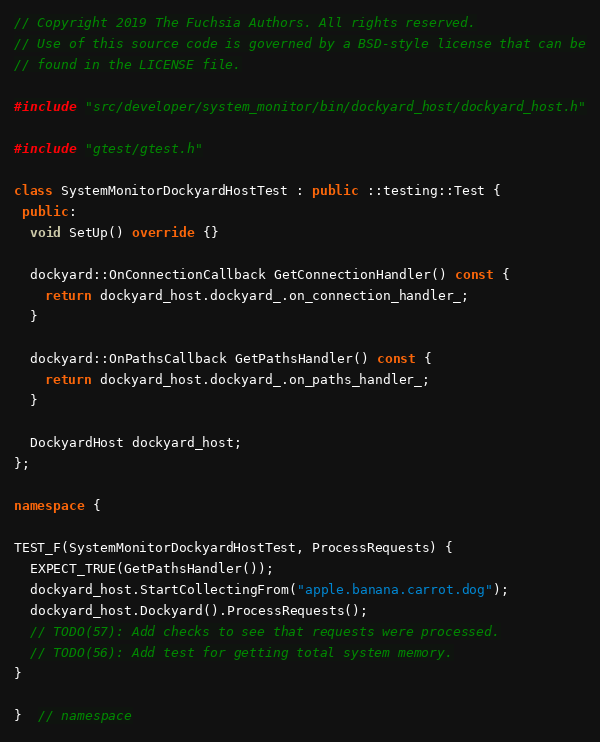<code> <loc_0><loc_0><loc_500><loc_500><_C++_>// Copyright 2019 The Fuchsia Authors. All rights reserved.
// Use of this source code is governed by a BSD-style license that can be
// found in the LICENSE file.

#include "src/developer/system_monitor/bin/dockyard_host/dockyard_host.h"

#include "gtest/gtest.h"

class SystemMonitorDockyardHostTest : public ::testing::Test {
 public:
  void SetUp() override {}

  dockyard::OnConnectionCallback GetConnectionHandler() const {
    return dockyard_host.dockyard_.on_connection_handler_;
  }

  dockyard::OnPathsCallback GetPathsHandler() const {
    return dockyard_host.dockyard_.on_paths_handler_;
  }

  DockyardHost dockyard_host;
};

namespace {

TEST_F(SystemMonitorDockyardHostTest, ProcessRequests) {
  EXPECT_TRUE(GetPathsHandler());
  dockyard_host.StartCollectingFrom("apple.banana.carrot.dog");
  dockyard_host.Dockyard().ProcessRequests();
  // TODO(57): Add checks to see that requests were processed.
  // TODO(56): Add test for getting total system memory.
}

}  // namespace
</code> 